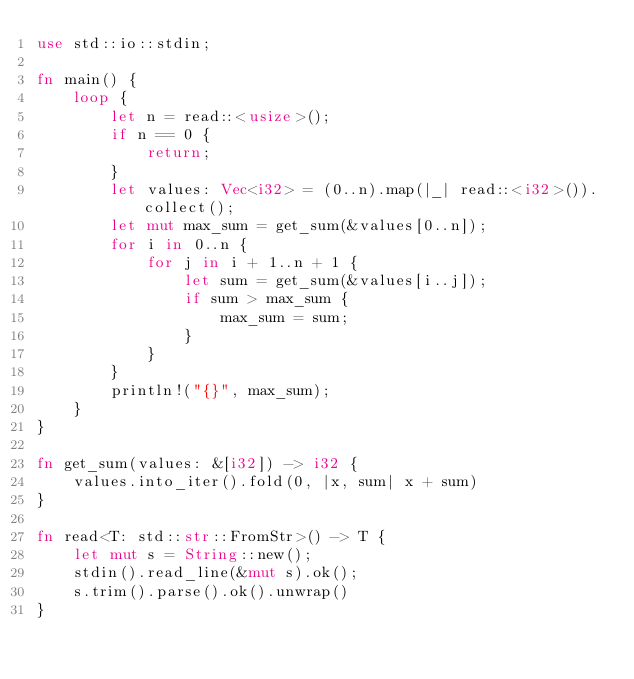<code> <loc_0><loc_0><loc_500><loc_500><_Rust_>use std::io::stdin;

fn main() {
    loop {
        let n = read::<usize>();
        if n == 0 {
            return;
        }
        let values: Vec<i32> = (0..n).map(|_| read::<i32>()).collect();
        let mut max_sum = get_sum(&values[0..n]);
        for i in 0..n {
            for j in i + 1..n + 1 {
                let sum = get_sum(&values[i..j]);
                if sum > max_sum {
                    max_sum = sum;
                }
            }
        }
        println!("{}", max_sum);
    }
}

fn get_sum(values: &[i32]) -> i32 {
    values.into_iter().fold(0, |x, sum| x + sum)
}

fn read<T: std::str::FromStr>() -> T {
    let mut s = String::new();
    stdin().read_line(&mut s).ok();
    s.trim().parse().ok().unwrap()
}

</code> 